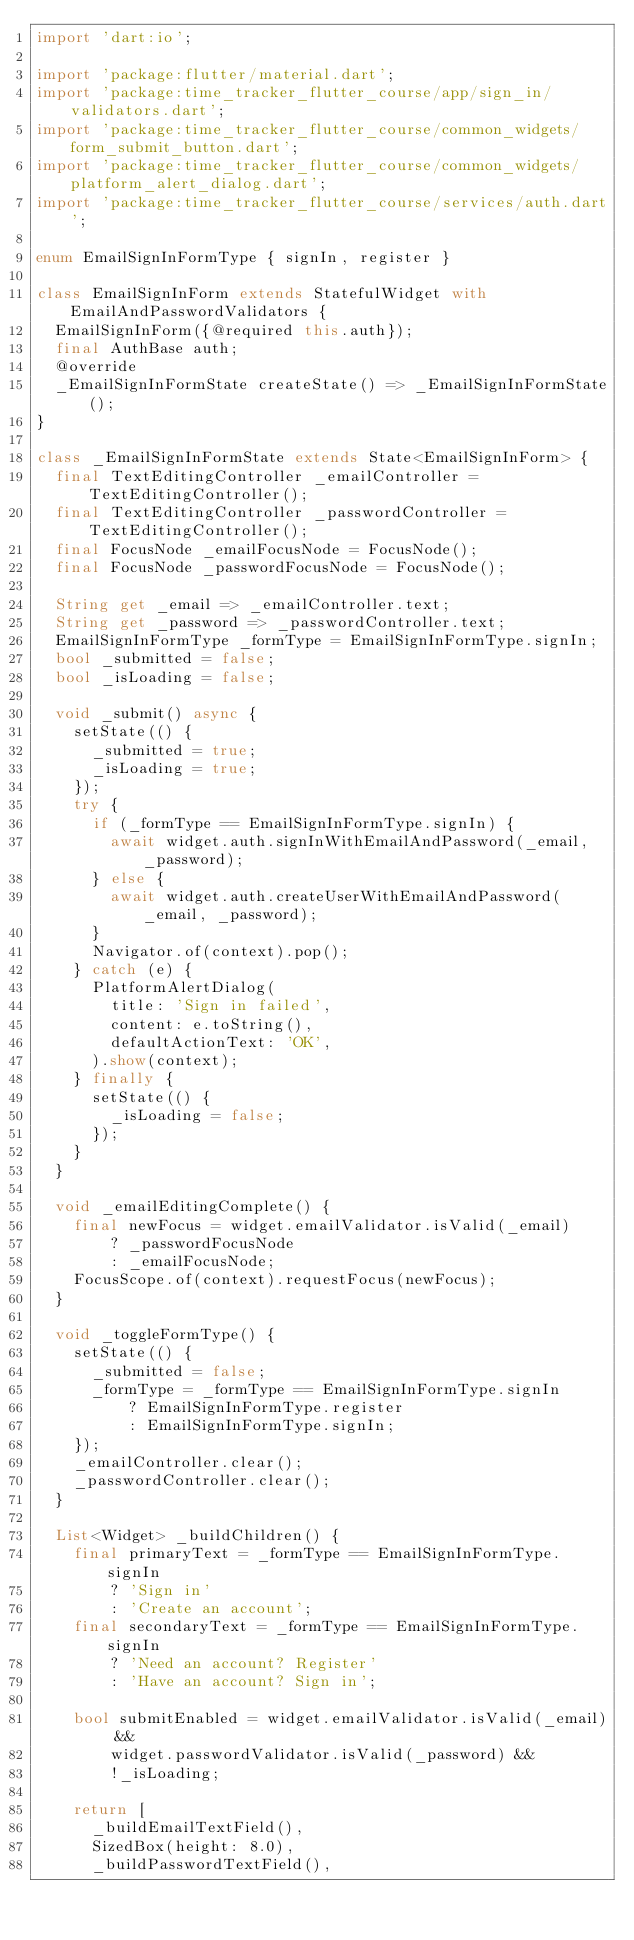Convert code to text. <code><loc_0><loc_0><loc_500><loc_500><_Dart_>import 'dart:io';

import 'package:flutter/material.dart';
import 'package:time_tracker_flutter_course/app/sign_in/validators.dart';
import 'package:time_tracker_flutter_course/common_widgets/form_submit_button.dart';
import 'package:time_tracker_flutter_course/common_widgets/platform_alert_dialog.dart';
import 'package:time_tracker_flutter_course/services/auth.dart';

enum EmailSignInFormType { signIn, register }

class EmailSignInForm extends StatefulWidget with EmailAndPasswordValidators {
  EmailSignInForm({@required this.auth});
  final AuthBase auth;
  @override
  _EmailSignInFormState createState() => _EmailSignInFormState();
}

class _EmailSignInFormState extends State<EmailSignInForm> {
  final TextEditingController _emailController = TextEditingController();
  final TextEditingController _passwordController = TextEditingController();
  final FocusNode _emailFocusNode = FocusNode();
  final FocusNode _passwordFocusNode = FocusNode();

  String get _email => _emailController.text;
  String get _password => _passwordController.text;
  EmailSignInFormType _formType = EmailSignInFormType.signIn;
  bool _submitted = false;
  bool _isLoading = false;

  void _submit() async {
    setState(() {
      _submitted = true;
      _isLoading = true;
    });
    try {
      if (_formType == EmailSignInFormType.signIn) {
        await widget.auth.signInWithEmailAndPassword(_email, _password);
      } else {
        await widget.auth.createUserWithEmailAndPassword(_email, _password);
      }
      Navigator.of(context).pop();
    } catch (e) {
      PlatformAlertDialog(
        title: 'Sign in failed',
        content: e.toString(),
        defaultActionText: 'OK',
      ).show(context);
    } finally {
      setState(() {
        _isLoading = false;
      });
    }
  }

  void _emailEditingComplete() {
    final newFocus = widget.emailValidator.isValid(_email)
        ? _passwordFocusNode
        : _emailFocusNode;
    FocusScope.of(context).requestFocus(newFocus);
  }

  void _toggleFormType() {
    setState(() {
      _submitted = false;
      _formType = _formType == EmailSignInFormType.signIn
          ? EmailSignInFormType.register
          : EmailSignInFormType.signIn;
    });
    _emailController.clear();
    _passwordController.clear();
  }

  List<Widget> _buildChildren() {
    final primaryText = _formType == EmailSignInFormType.signIn
        ? 'Sign in'
        : 'Create an account';
    final secondaryText = _formType == EmailSignInFormType.signIn
        ? 'Need an account? Register'
        : 'Have an account? Sign in';

    bool submitEnabled = widget.emailValidator.isValid(_email) &&
        widget.passwordValidator.isValid(_password) &&
        !_isLoading;

    return [
      _buildEmailTextField(),
      SizedBox(height: 8.0),
      _buildPasswordTextField(),</code> 